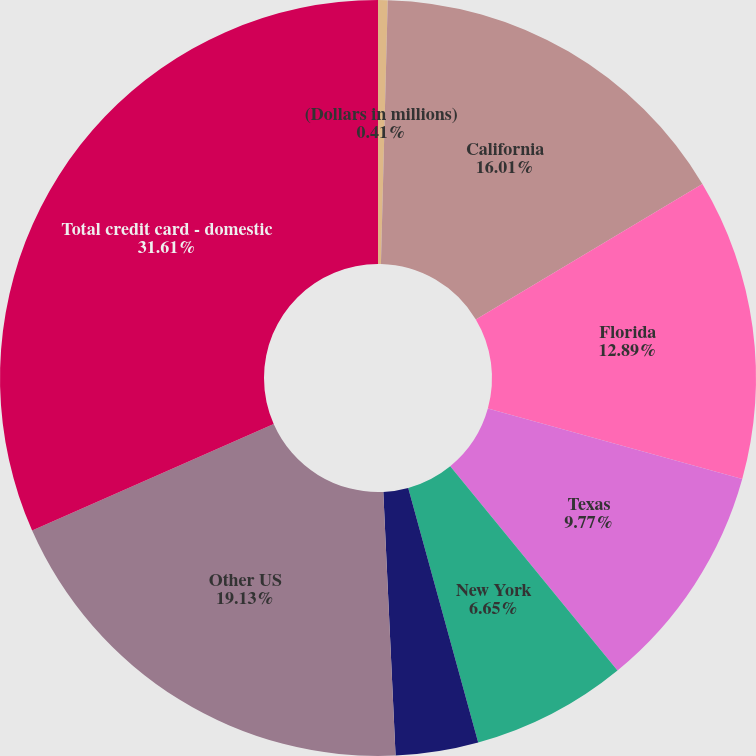Convert chart to OTSL. <chart><loc_0><loc_0><loc_500><loc_500><pie_chart><fcel>(Dollars in millions)<fcel>California<fcel>Florida<fcel>Texas<fcel>New York<fcel>New Jersey<fcel>Other US<fcel>Total credit card - domestic<nl><fcel>0.41%<fcel>16.01%<fcel>12.89%<fcel>9.77%<fcel>6.65%<fcel>3.53%<fcel>19.13%<fcel>31.61%<nl></chart> 